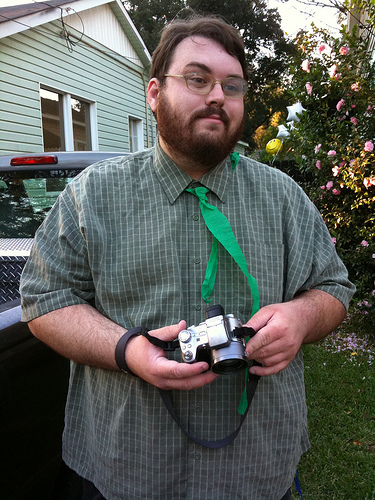What vehicle is it?
Answer the question using a single word or phrase. Truck What's the man holding? Camera What is he holding? Camera What device is it? Camera What are the roses on? Bush Are the roses on the shrub? Yes What device is the man holding? Camera Which kind of vehicle is to the left of the camera? Truck Is the truck on the right side? No Is the beard brown or blond? Brown What is the device that is to the right of the vehicle that is on the left of the photo? Camera Does the grass look green? Yes He is in front of what? Building What color is the shirt, green or white? Green 